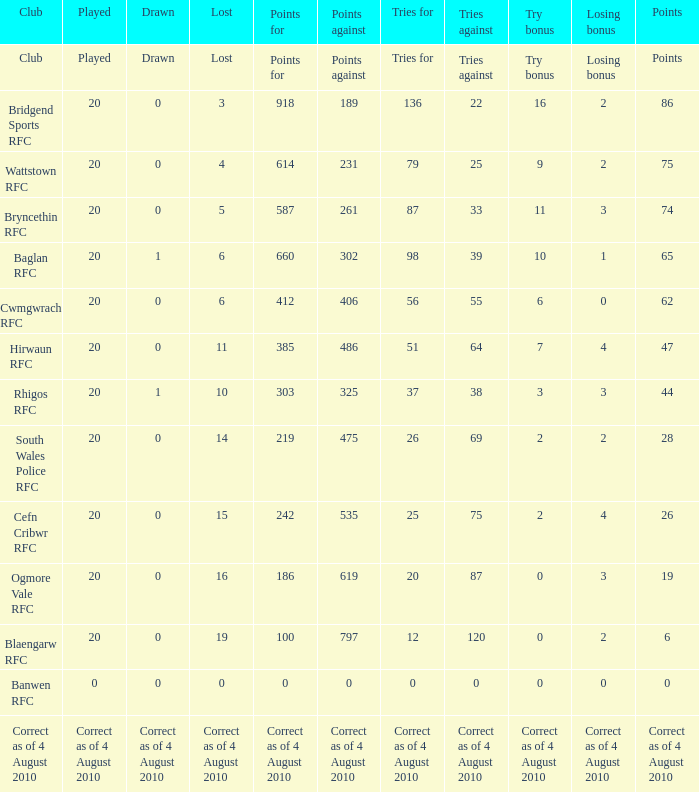What is depicted when the club in question is hirwaun rfc? 0.0. 